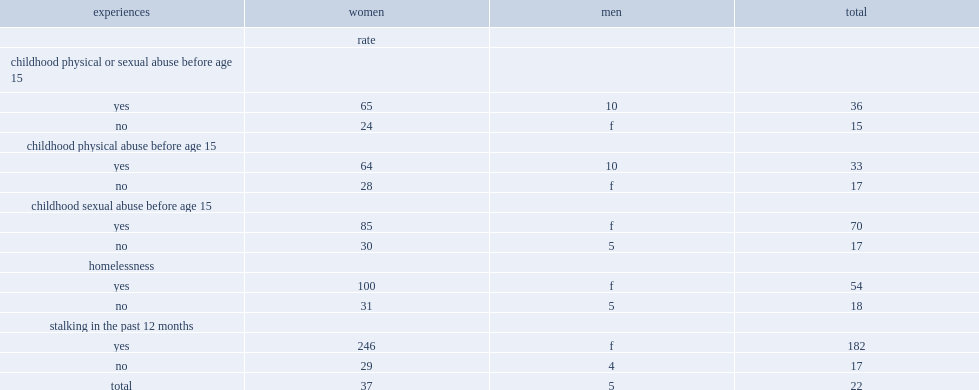Considering whether experience childhood physical or sexual abuse before age 15,which kind of people have higher rate of sexual assault?had experienced or not? Yes. What was the times that the rate of sex assault of people who had experienced childhood sexual abuse higher than the rate of those who had not been abused? 4.117647. Among people who had experienced either type of abuse during childhood,what was the rate of sexual assault of women higher than the rate of men? 6.5. Among people experienced homelessness and people did not experience homelessness,which kind of people have higher rate of sexual assault? Yes. What was the times the rate of sexual assault of people had ever experienced homelessness higher than the rate of those who had never been homeless? 3. 